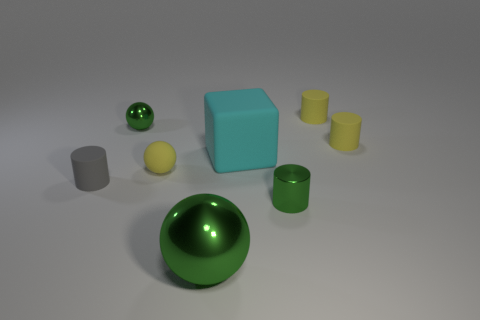There is a tiny sphere that is the same color as the shiny cylinder; what material is it? metal 